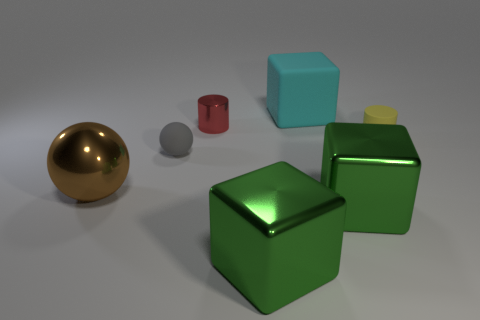Subtract all large metal cubes. How many cubes are left? 1 Subtract all purple cylinders. How many green blocks are left? 2 Subtract all green blocks. How many blocks are left? 1 Subtract all spheres. How many objects are left? 5 Add 1 cylinders. How many objects exist? 8 Subtract 1 cylinders. How many cylinders are left? 1 Subtract all green balls. Subtract all cyan cylinders. How many balls are left? 2 Subtract all large shiny balls. Subtract all big brown spheres. How many objects are left? 5 Add 3 red cylinders. How many red cylinders are left? 4 Add 5 yellow objects. How many yellow objects exist? 6 